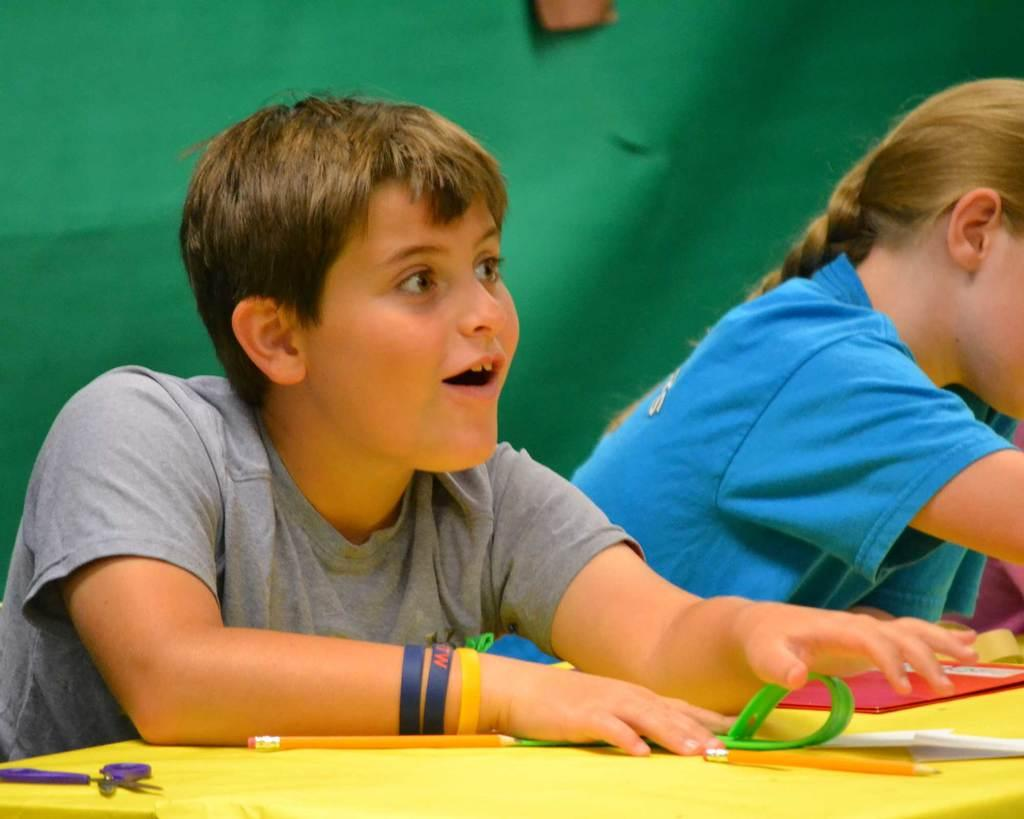Who is the main subject in the image? There is a boy in the image. What is the boy doing in the image? The boy is sitting on a stool. Where is the stool located in relation to the table? The stool is in front of a table. What objects can be seen on the table? There is a scissors, a pencil, and papers on the table. Can you see the boy's head through the window in the image? There is no window present in the image, so it is not possible to see the boy's head through a window. 